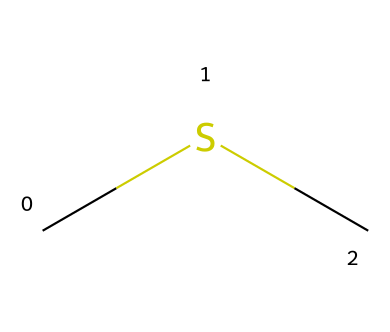What is the chemical name of this compound? The SMILES representation "CSC" corresponds to a molecule with two methyl (CH3) groups bonded to a sulfur (S) atom. Therefore, the chemical name is dimethyl sulfide.
Answer: dimethyl sulfide How many carbon atoms are present in this structure? In the SMILES "CSC," there are two 'C' letters, which represent two carbon atoms in the molecule.
Answer: 2 What type of bond connects the carbon atoms in this compound? The "C" in "CSC" suggests that the carbon atoms are connected to sulfur and to each other through single bonds, characteristic of saturated hydrocarbons.
Answer: single bond What is the molecular formula for dimethyl sulfide? The compound consists of 2 carbon atoms, 6 hydrogen atoms (from the two CH3 groups), and 1 sulfur atom, giving the molecular formula C2H6S.
Answer: C2H6S How does the presence of sulfur influence the aroma of this compound? The sulfur atom contributes to the unique odor profile of the compound, as many organosulfur compounds are known for having strong and distinct aromas, which is true for dimethyl sulfide as it adds a savory, umami flavor.
Answer: strong aroma Is dimethyl sulfide considered an organosulfur compound? Yes, dimethyl sulfide contains sulfur within its molecular structure, classifying it as an organosulfur compound, which is defined by the presence of carbon-thiolate bonds.
Answer: Yes 